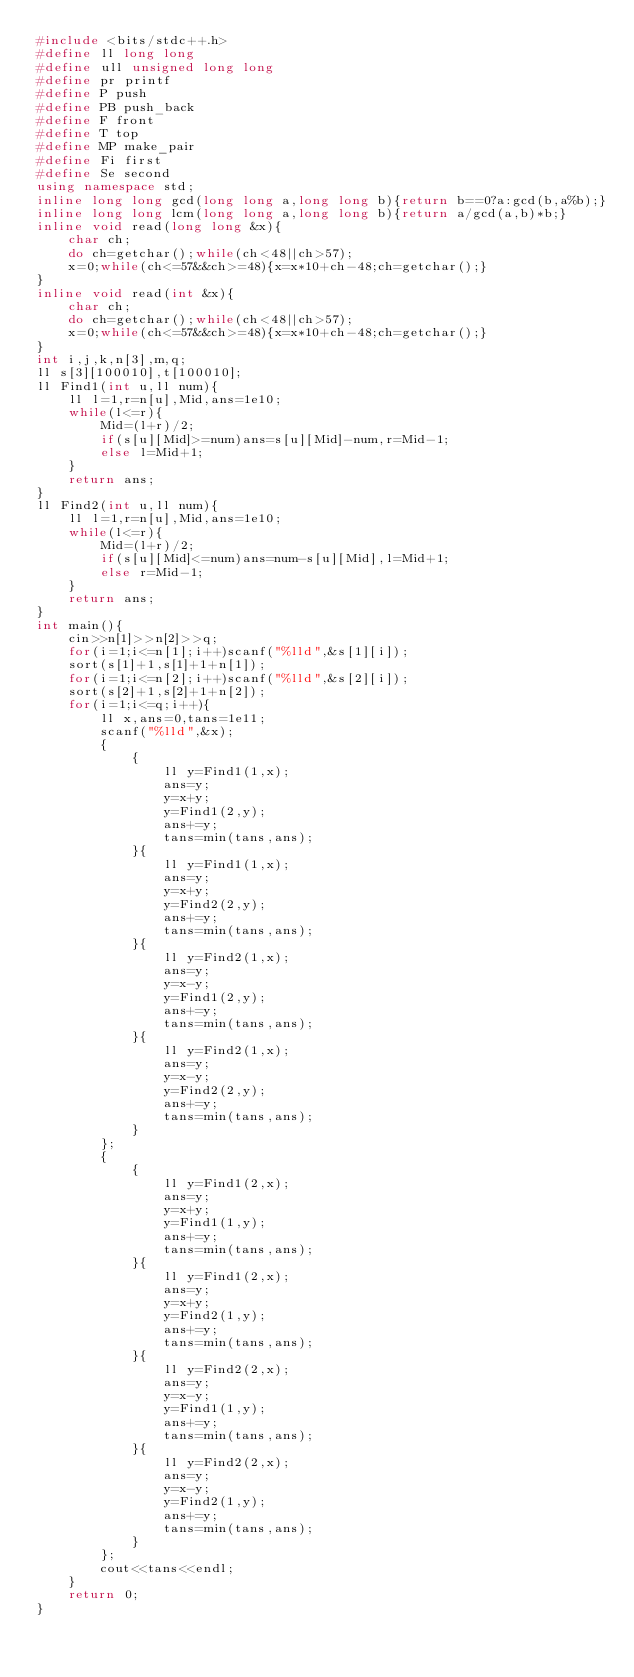Convert code to text. <code><loc_0><loc_0><loc_500><loc_500><_C++_>#include <bits/stdc++.h>
#define ll long long
#define ull unsigned long long
#define pr printf
#define P push
#define PB push_back
#define F front
#define T top
#define MP make_pair
#define Fi first
#define Se second
using namespace std;
inline long long gcd(long long a,long long b){return b==0?a:gcd(b,a%b);}
inline long long lcm(long long a,long long b){return a/gcd(a,b)*b;}
inline void read(long long &x){
	char ch;
	do ch=getchar();while(ch<48||ch>57);
	x=0;while(ch<=57&&ch>=48){x=x*10+ch-48;ch=getchar();}
}
inline void read(int &x){
	char ch;
	do ch=getchar();while(ch<48||ch>57);
	x=0;while(ch<=57&&ch>=48){x=x*10+ch-48;ch=getchar();}
}
int i,j,k,n[3],m,q;
ll s[3][100010],t[100010];
ll Find1(int u,ll num){
	ll l=1,r=n[u],Mid,ans=1e10;
	while(l<=r){
		Mid=(l+r)/2;
		if(s[u][Mid]>=num)ans=s[u][Mid]-num,r=Mid-1;
		else l=Mid+1;
	}
	return ans;
}
ll Find2(int u,ll num){
	ll l=1,r=n[u],Mid,ans=1e10;
	while(l<=r){
		Mid=(l+r)/2;
		if(s[u][Mid]<=num)ans=num-s[u][Mid],l=Mid+1;
		else r=Mid-1;
	}
	return ans;
}
int main(){
	cin>>n[1]>>n[2]>>q;
	for(i=1;i<=n[1];i++)scanf("%lld",&s[1][i]);
	sort(s[1]+1,s[1]+1+n[1]);
	for(i=1;i<=n[2];i++)scanf("%lld",&s[2][i]);
	sort(s[2]+1,s[2]+1+n[2]);
	for(i=1;i<=q;i++){
		ll x,ans=0,tans=1e11;
		scanf("%lld",&x);
		{
			{
				ll y=Find1(1,x);
				ans=y;
				y=x+y;
				y=Find1(2,y);
				ans+=y;
				tans=min(tans,ans);
			}{
				ll y=Find1(1,x);
				ans=y;
				y=x+y;
				y=Find2(2,y);
				ans+=y;
				tans=min(tans,ans);
			}{
				ll y=Find2(1,x);
				ans=y;
				y=x-y;
				y=Find1(2,y);
				ans+=y;
				tans=min(tans,ans);
			}{
				ll y=Find2(1,x);
				ans=y;
				y=x-y;
				y=Find2(2,y);
				ans+=y;
				tans=min(tans,ans);
			}
		};
		{
			{
				ll y=Find1(2,x);
				ans=y;
				y=x+y;
				y=Find1(1,y);
				ans+=y;
				tans=min(tans,ans);
			}{
				ll y=Find1(2,x);
				ans=y;
				y=x+y;
				y=Find2(1,y);
				ans+=y;
				tans=min(tans,ans);
			}{
				ll y=Find2(2,x);
				ans=y;
				y=x-y;
				y=Find1(1,y);
				ans+=y;
				tans=min(tans,ans);
			}{
				ll y=Find2(2,x);
				ans=y;
				y=x-y;
				y=Find2(1,y);
				ans+=y;
				tans=min(tans,ans);
			}
		};
		cout<<tans<<endl;
	}
	return 0;
}</code> 